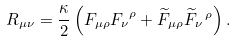<formula> <loc_0><loc_0><loc_500><loc_500>R _ { \mu \nu } = \frac { \kappa } { 2 } \left ( F _ { \mu \rho } { F _ { \nu } } ^ { \rho } + \widetilde { F } _ { \mu \rho } { \widetilde { F } _ { \nu } } \, ^ { \rho } \right ) .</formula> 